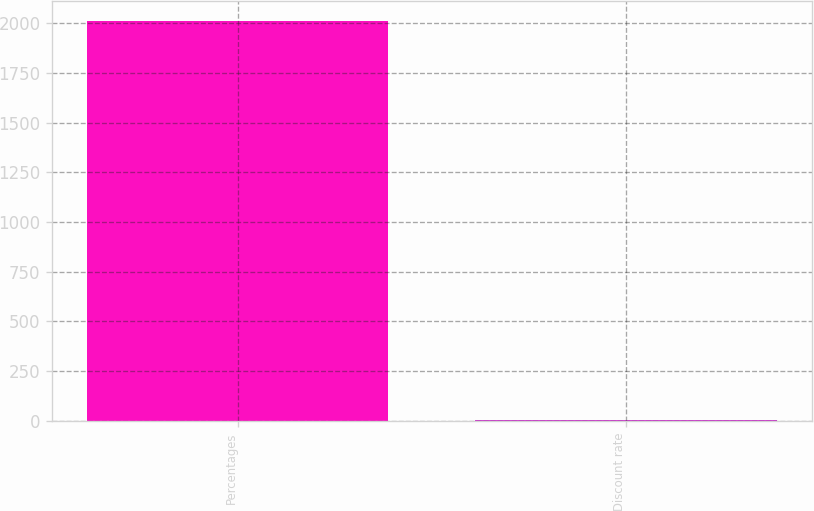Convert chart to OTSL. <chart><loc_0><loc_0><loc_500><loc_500><bar_chart><fcel>Percentages<fcel>Discount rate<nl><fcel>2010<fcel>5.35<nl></chart> 